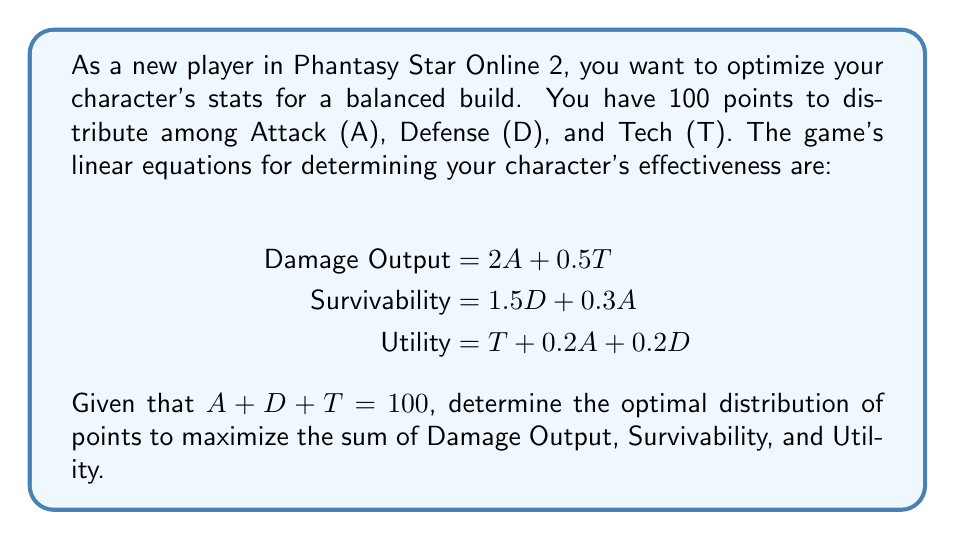Teach me how to tackle this problem. Let's approach this step-by-step:

1) First, we need to create an equation that represents the total effectiveness (E) of the character:

   $$E = (2A + 0.5T) + (1.5D + 0.3A) + (T + 0.2A + 0.2D)$$

2) Simplify this equation:

   $$E = 2.5A + 1.7D + 1.5T$$

3) We know that $A + D + T = 100$, so we can express T in terms of A and D:

   $$T = 100 - A - D$$

4) Substitute this into our effectiveness equation:

   $$E = 2.5A + 1.7D + 1.5(100 - A - D)$$

5) Simplify:

   $$E = 2.5A + 1.7D + 150 - 1.5A - 1.5D$$
   $$E = A + 0.2D + 150$$

6) To maximize E, we need to maximize A and D. Since A has a larger coefficient, we should allocate as many points as possible to A.

7) The constraint $A + D + T = 100$ and the requirement that all stats must be positive means that we can't allocate all points to A. We need to keep some points for D and T.

8) A reasonable distribution that maximizes A while keeping D and T positive could be:

   $$A = 80, D = 10, T = 10$$

9) We can verify that this satisfies our constraint:

   $$80 + 10 + 10 = 100$$

10) Calculate the effectiveness with this distribution:

    $$E = 80 + 0.2(10) + 150 = 232$$

This distribution maximizes the effectiveness given the constraints.
Answer: The optimal distribution is approximately: Attack (A) = 80, Defense (D) = 10, Tech (T) = 10. This results in a total effectiveness of 232. 